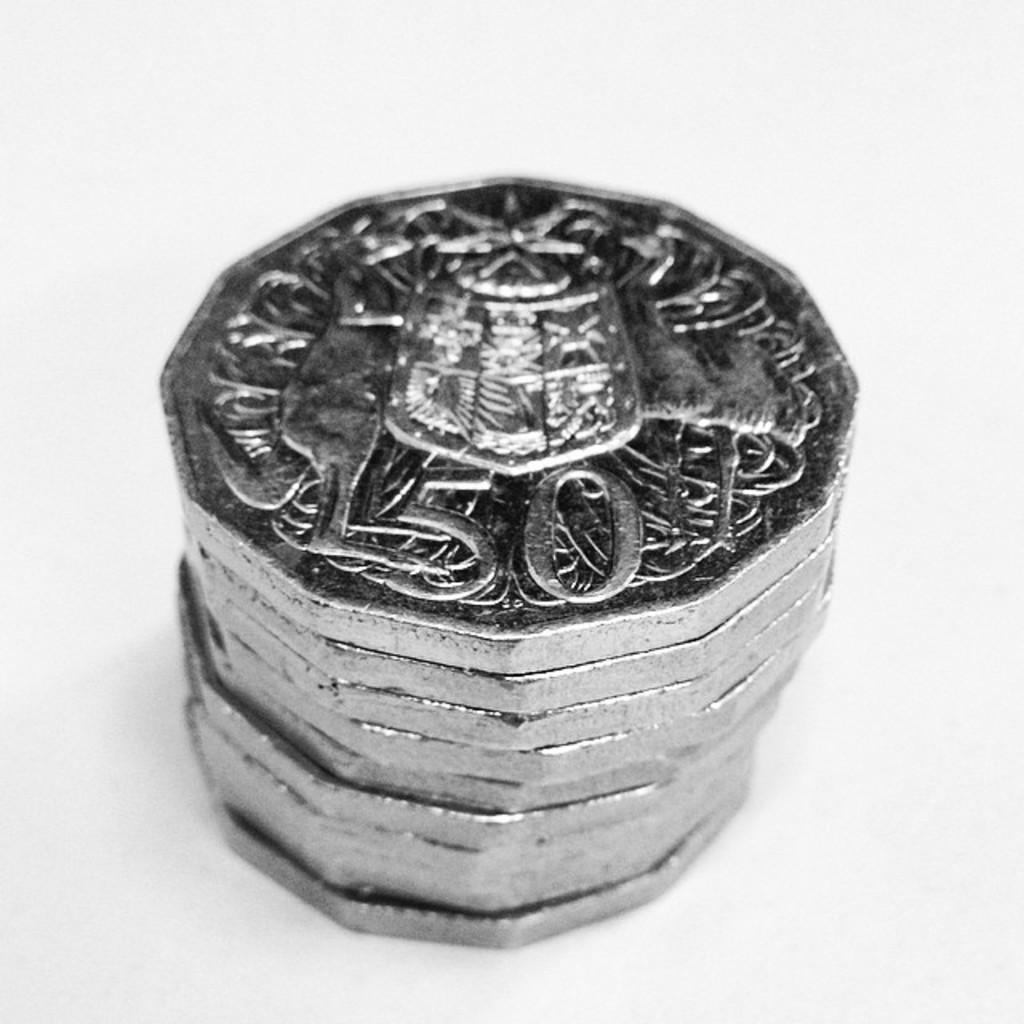<image>
Render a clear and concise summary of the photo. A stack of flat edged silver coins with a 50 and a crest on them. 